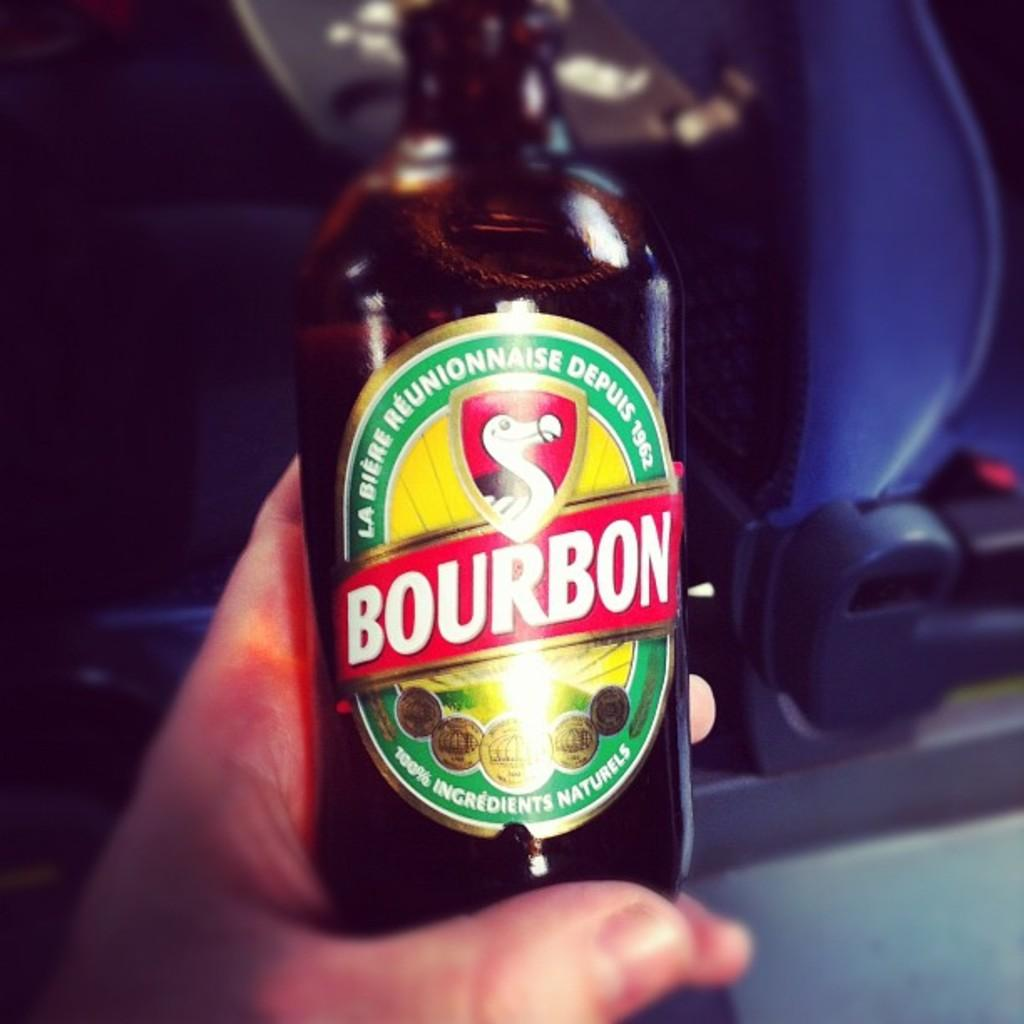What is the main object being held in the image? There is a bottle with a sticker in the image, and a person's hand is holding it. What can be seen in the background of the image? There is a seat in the background of the image, and the background is dark. What type of teeth can be seen on the beast in the image? There is no beast or teeth present in the image; it features a person holding a bottle with a sticker. How does the person look at the bottle in the image? The image does not show the person's facial expression or how they are looking at the bottle. 